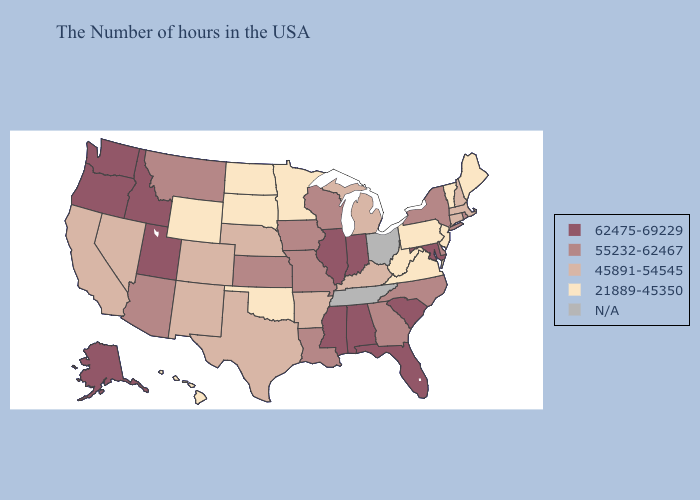Is the legend a continuous bar?
Answer briefly. No. Does Idaho have the lowest value in the USA?
Answer briefly. No. Does Arkansas have the highest value in the South?
Be succinct. No. What is the value of Arkansas?
Quick response, please. 45891-54545. What is the highest value in states that border Arizona?
Give a very brief answer. 62475-69229. Name the states that have a value in the range 21889-45350?
Short answer required. Maine, Vermont, New Jersey, Pennsylvania, Virginia, West Virginia, Minnesota, Oklahoma, South Dakota, North Dakota, Wyoming, Hawaii. How many symbols are there in the legend?
Write a very short answer. 5. Does Wisconsin have the lowest value in the USA?
Short answer required. No. Among the states that border Kentucky , does West Virginia have the lowest value?
Be succinct. Yes. Name the states that have a value in the range 45891-54545?
Short answer required. Massachusetts, New Hampshire, Connecticut, Michigan, Kentucky, Arkansas, Nebraska, Texas, Colorado, New Mexico, Nevada, California. What is the value of Montana?
Write a very short answer. 55232-62467. Among the states that border North Dakota , does Montana have the highest value?
Quick response, please. Yes. Name the states that have a value in the range 21889-45350?
Concise answer only. Maine, Vermont, New Jersey, Pennsylvania, Virginia, West Virginia, Minnesota, Oklahoma, South Dakota, North Dakota, Wyoming, Hawaii. 